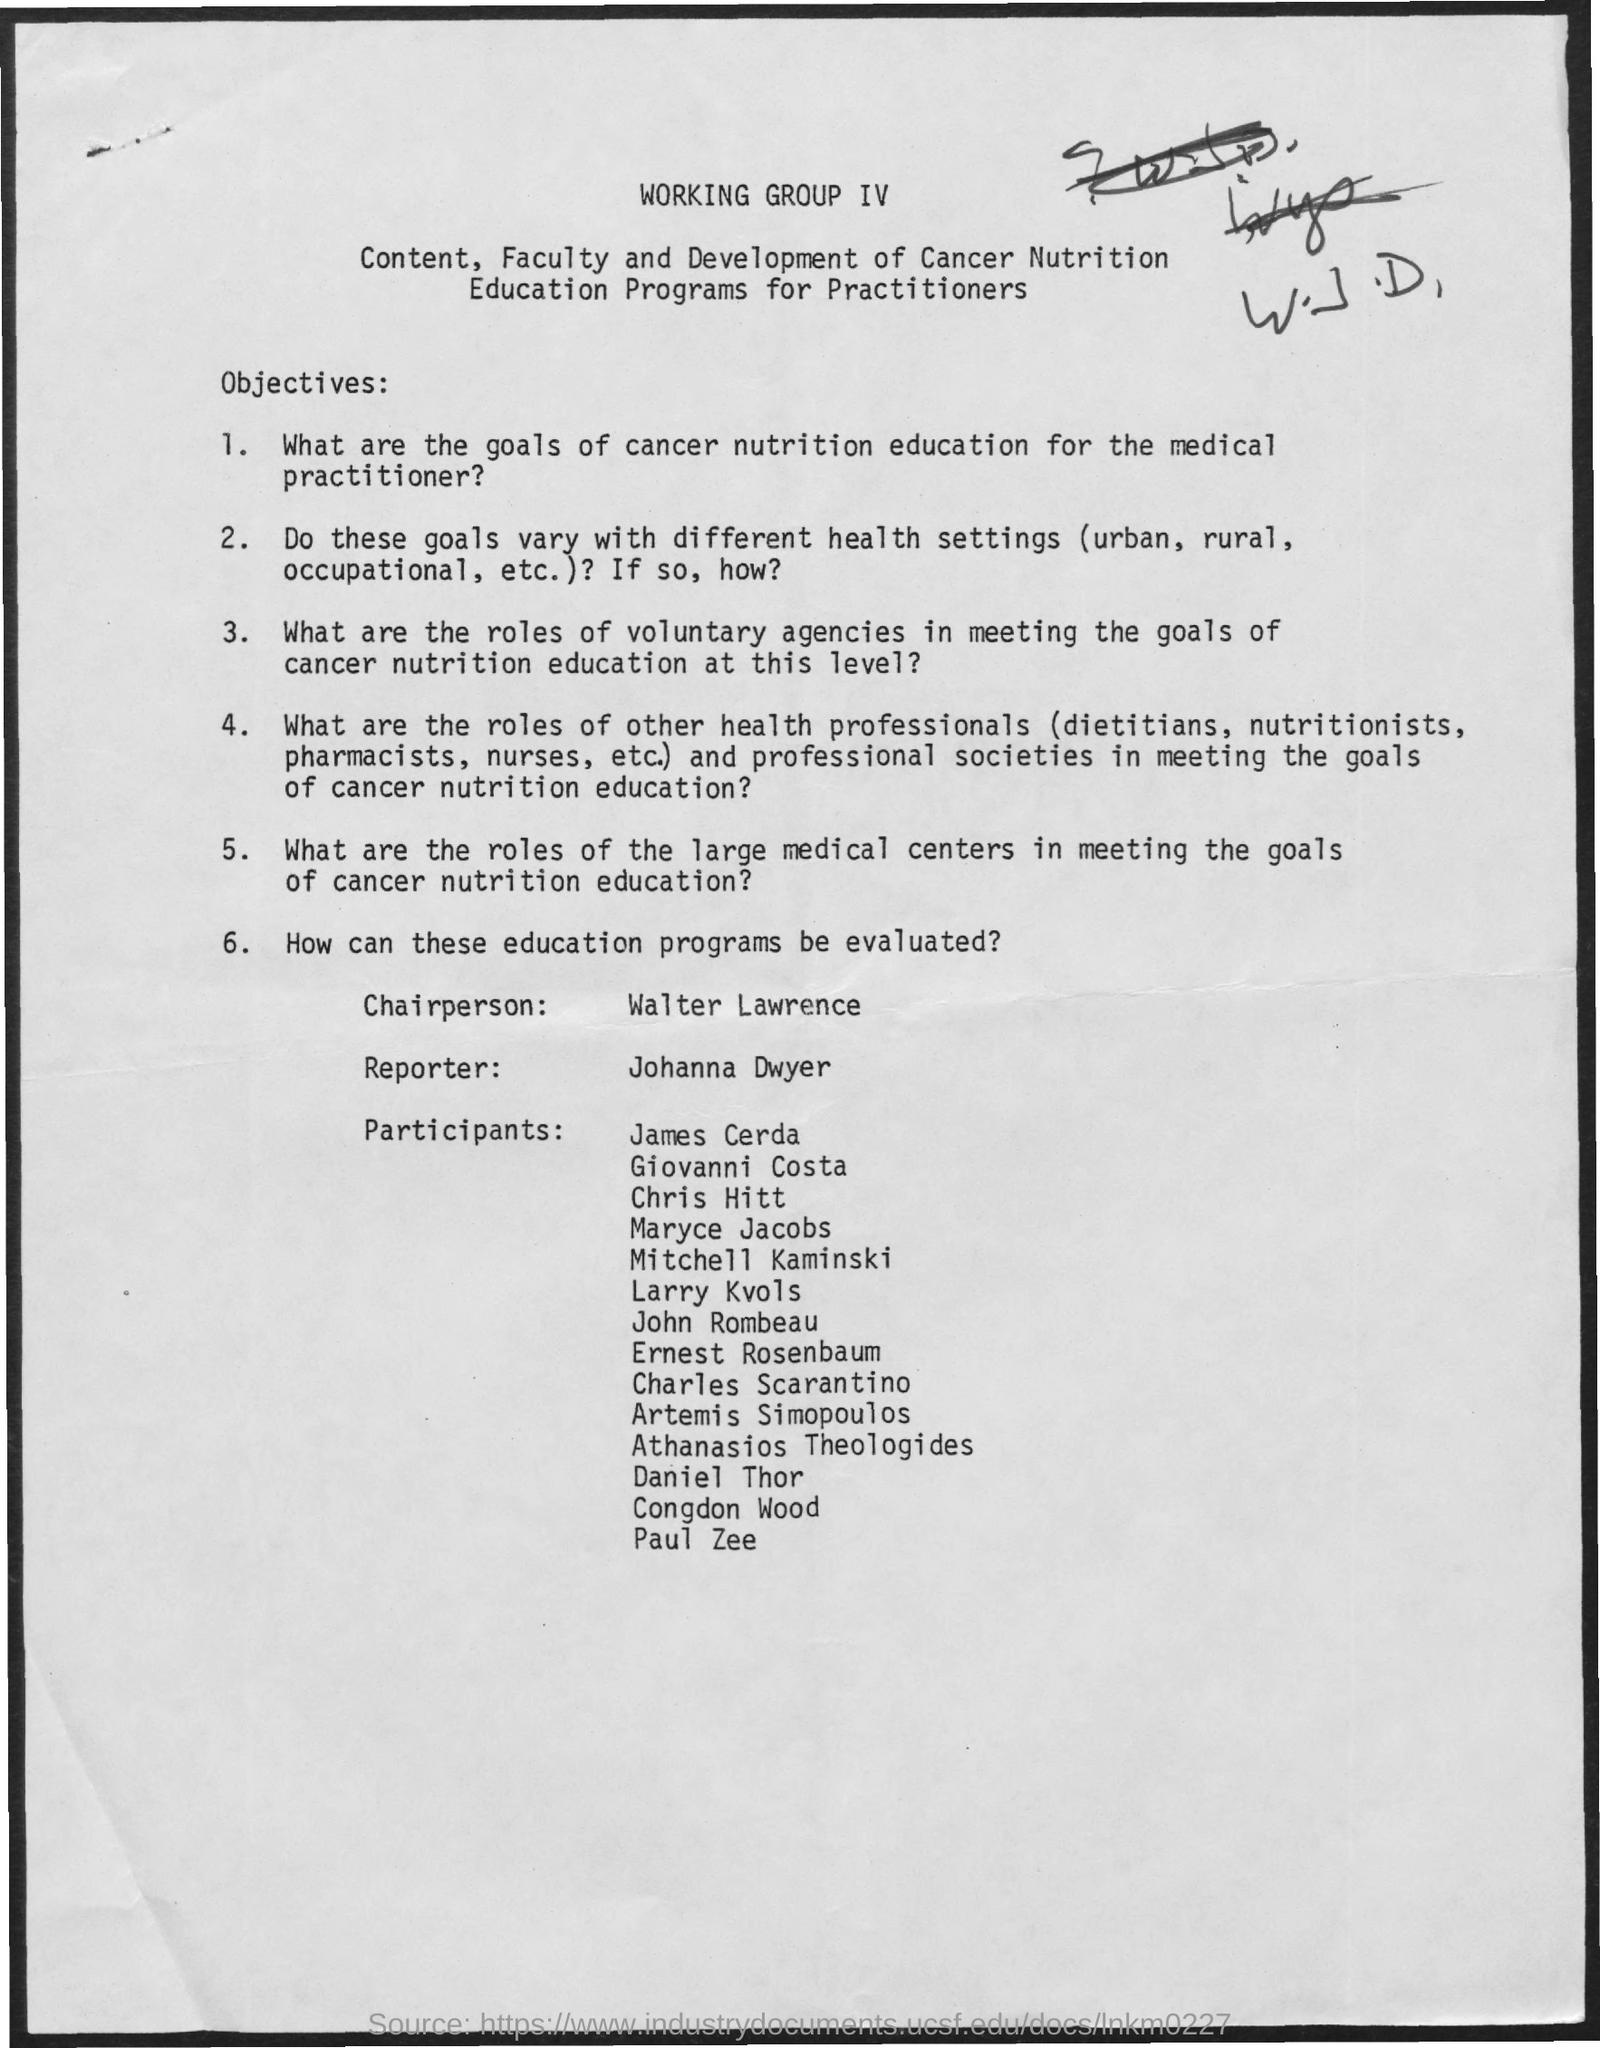Specify some key components in this picture. The reporter's name mentioned in the document is Johanna Dwyer. Walter Lawrence is the chairperson for the education programs. 